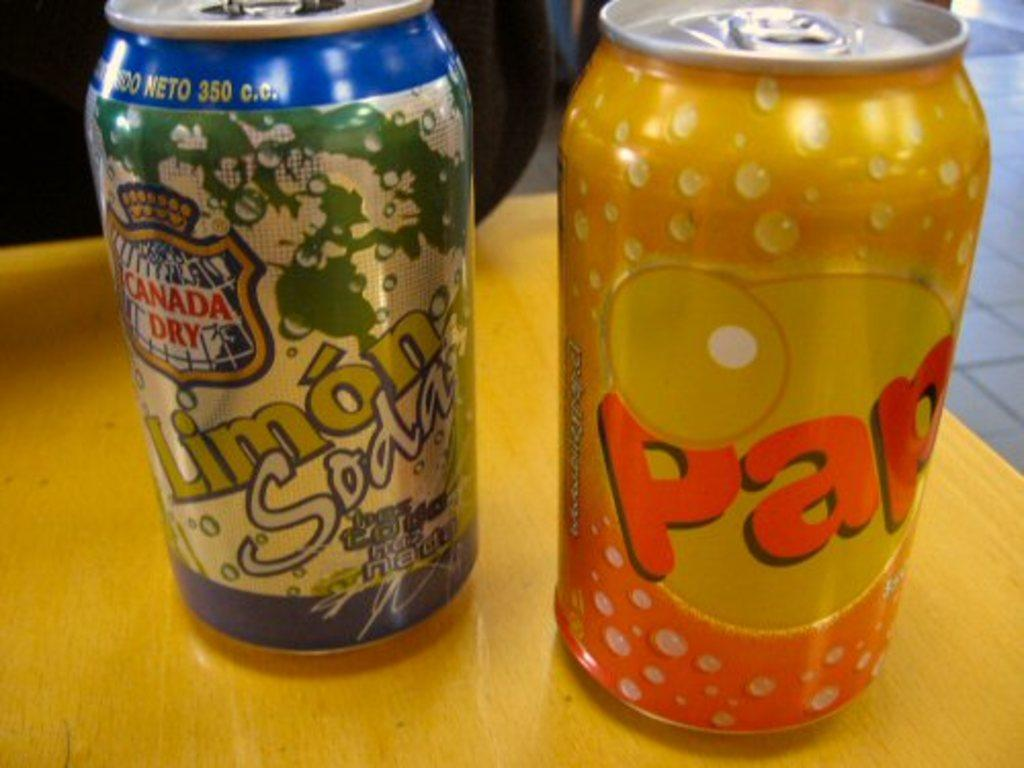<image>
Share a concise interpretation of the image provided. Two cans of soda, the one on the right being called Pap. 